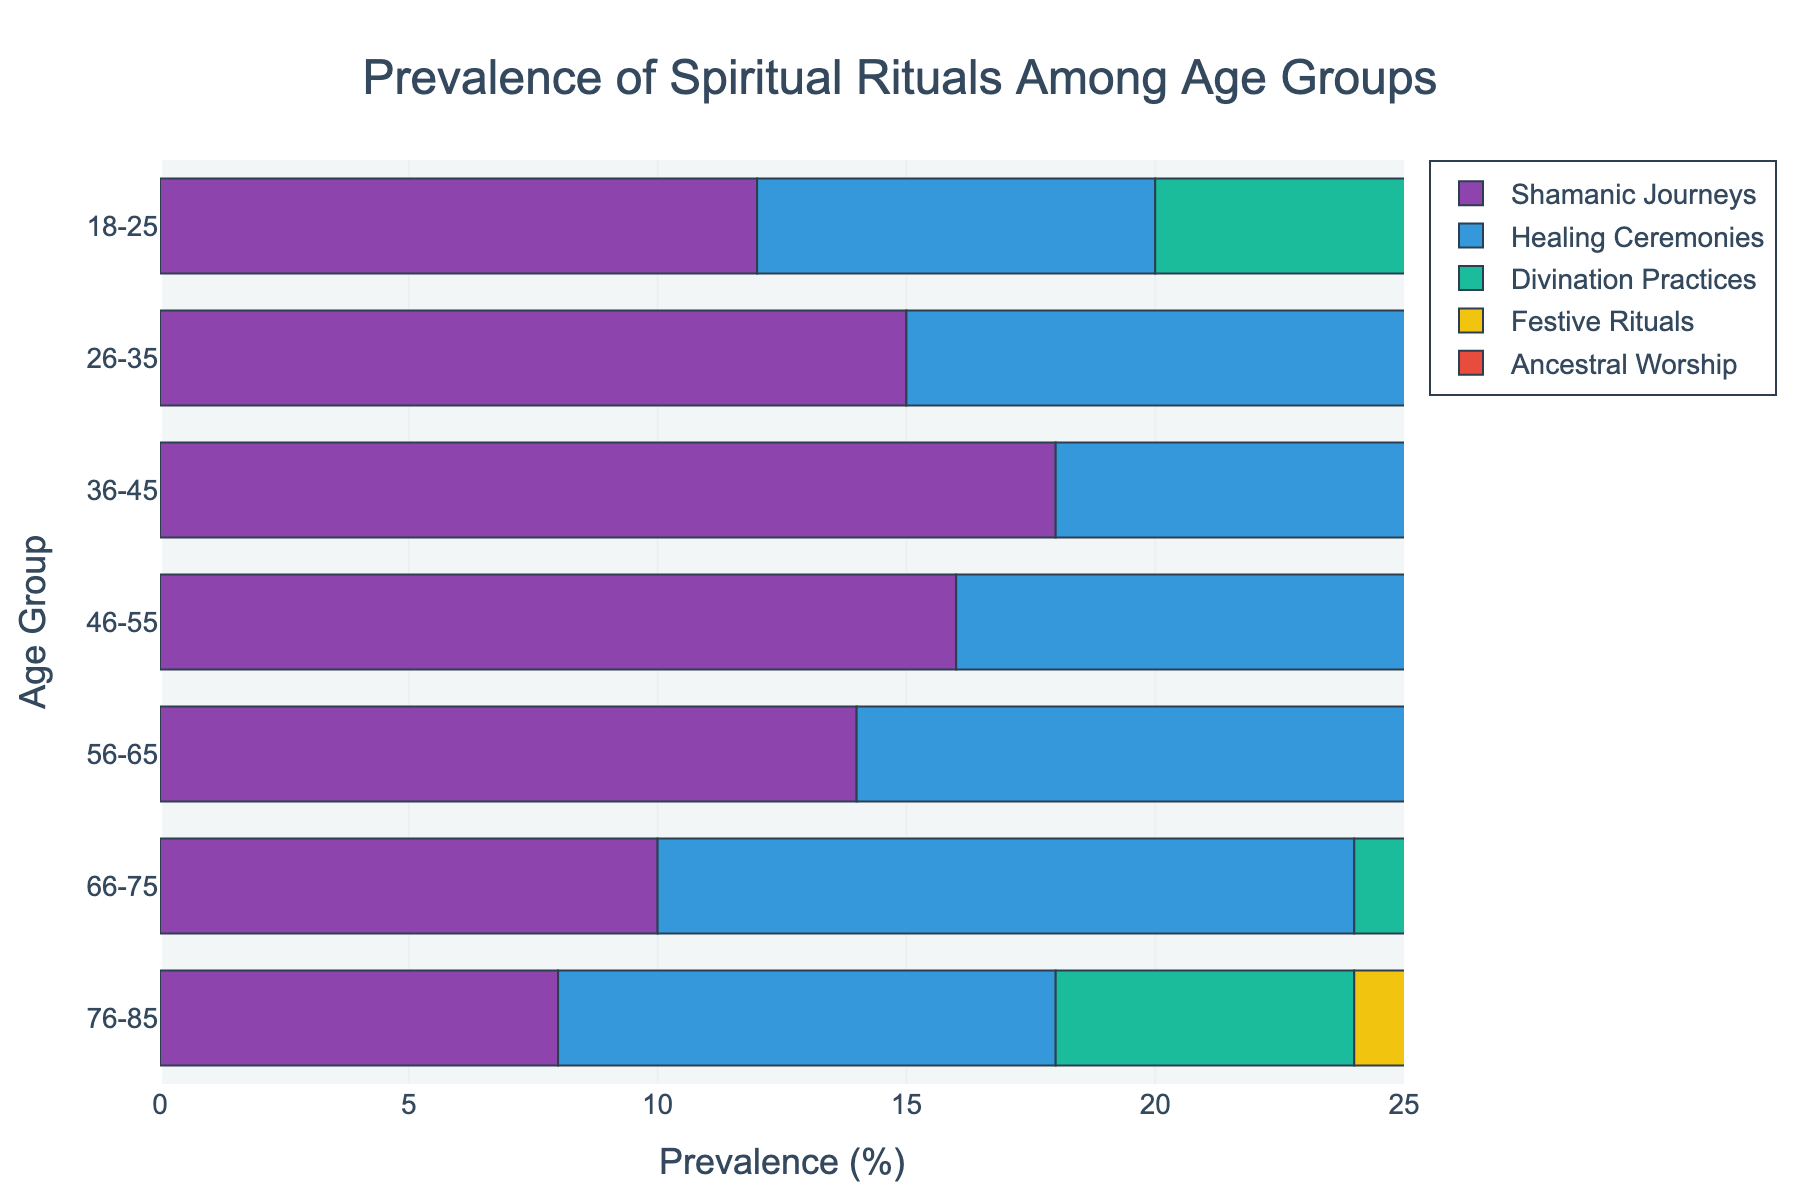What age group has the highest prevalence of Healing Ceremonies? Look at the length of the bar for Healing Ceremonies across all age groups. The bar corresponding to the age group 46-55 is the longest.
Answer: 46-55 Which type of ritual is most prevalent among the 36-45 age group? Compare the lengths of the bars within the 36-45 age group. The bar for Festive Rituals is the longest.
Answer: Festive Rituals How does the prevalence of Ancestral Worship change from the 18-25 age group to the 76-85 age group? Note the values for Ancestral Worship: it starts at 7 in the 18-25 age group and decreases to 5 in the 76-85 age group.
Answer: Decreases Which spiritual ritual has the smallest difference in prevalence between the 18-25 and 26-35 age groups? Calculate the differences for each ritual: Shamanic Journeys (3), Healing Ceremonies (4), Divination Practices (3), Festive Rituals (3), Ancestral Worship (2). The smallest difference is 2 for Ancestral Worship.
Answer: Ancestral Worship What is the total prevalence of all rituals for the 56-65 age group? Sum the values of all rituals for the 56-65 age group: 14 (Shamanic Journeys) + 18 (Healing Ceremonies) + 12 (Divination Practices) + 13 (Festive Rituals) + 9 (Ancestral Worship) = 66.
Answer: 66 How does the prevalence of Shamanic Journeys compare between the youngest and oldest age groups? Shamanic Journeys are 12% for the 18-25 age group and 8% for the 76-85 age group.
Answer: 18-25 > 76-85 What is the average prevalence of Divination Practices across all age groups? (10 + 13 + 14 + 15 + 12 + 8 + 6) / 7 = 78 / 7 ≈ 11.14
Answer: 11.14 Which age group shows the greatest total prevalence of all five rituals combined? Calculate the total for each age group and compare. The 36-45 age group has the highest total: 18 + 17 + 14 + 20 + 11 = 80.
Answer: 36-45 Does any age group have a prevalence of Divination Practices that exceeds the prevalence of Healing Ceremonies for the same group? Compare Divination Practices and Healing Ceremonies for each age group. In each group, Healing Ceremonies have higher values.
Answer: No Is there a noticeable trend in the prevalence of Festive Rituals as age increases? Observe Festive Rituals values: 15, 18, 20, 17, 13, 10, 7. There is a general decreasing trend with increasing age after the peak at 36-45.
Answer: Decreasing 